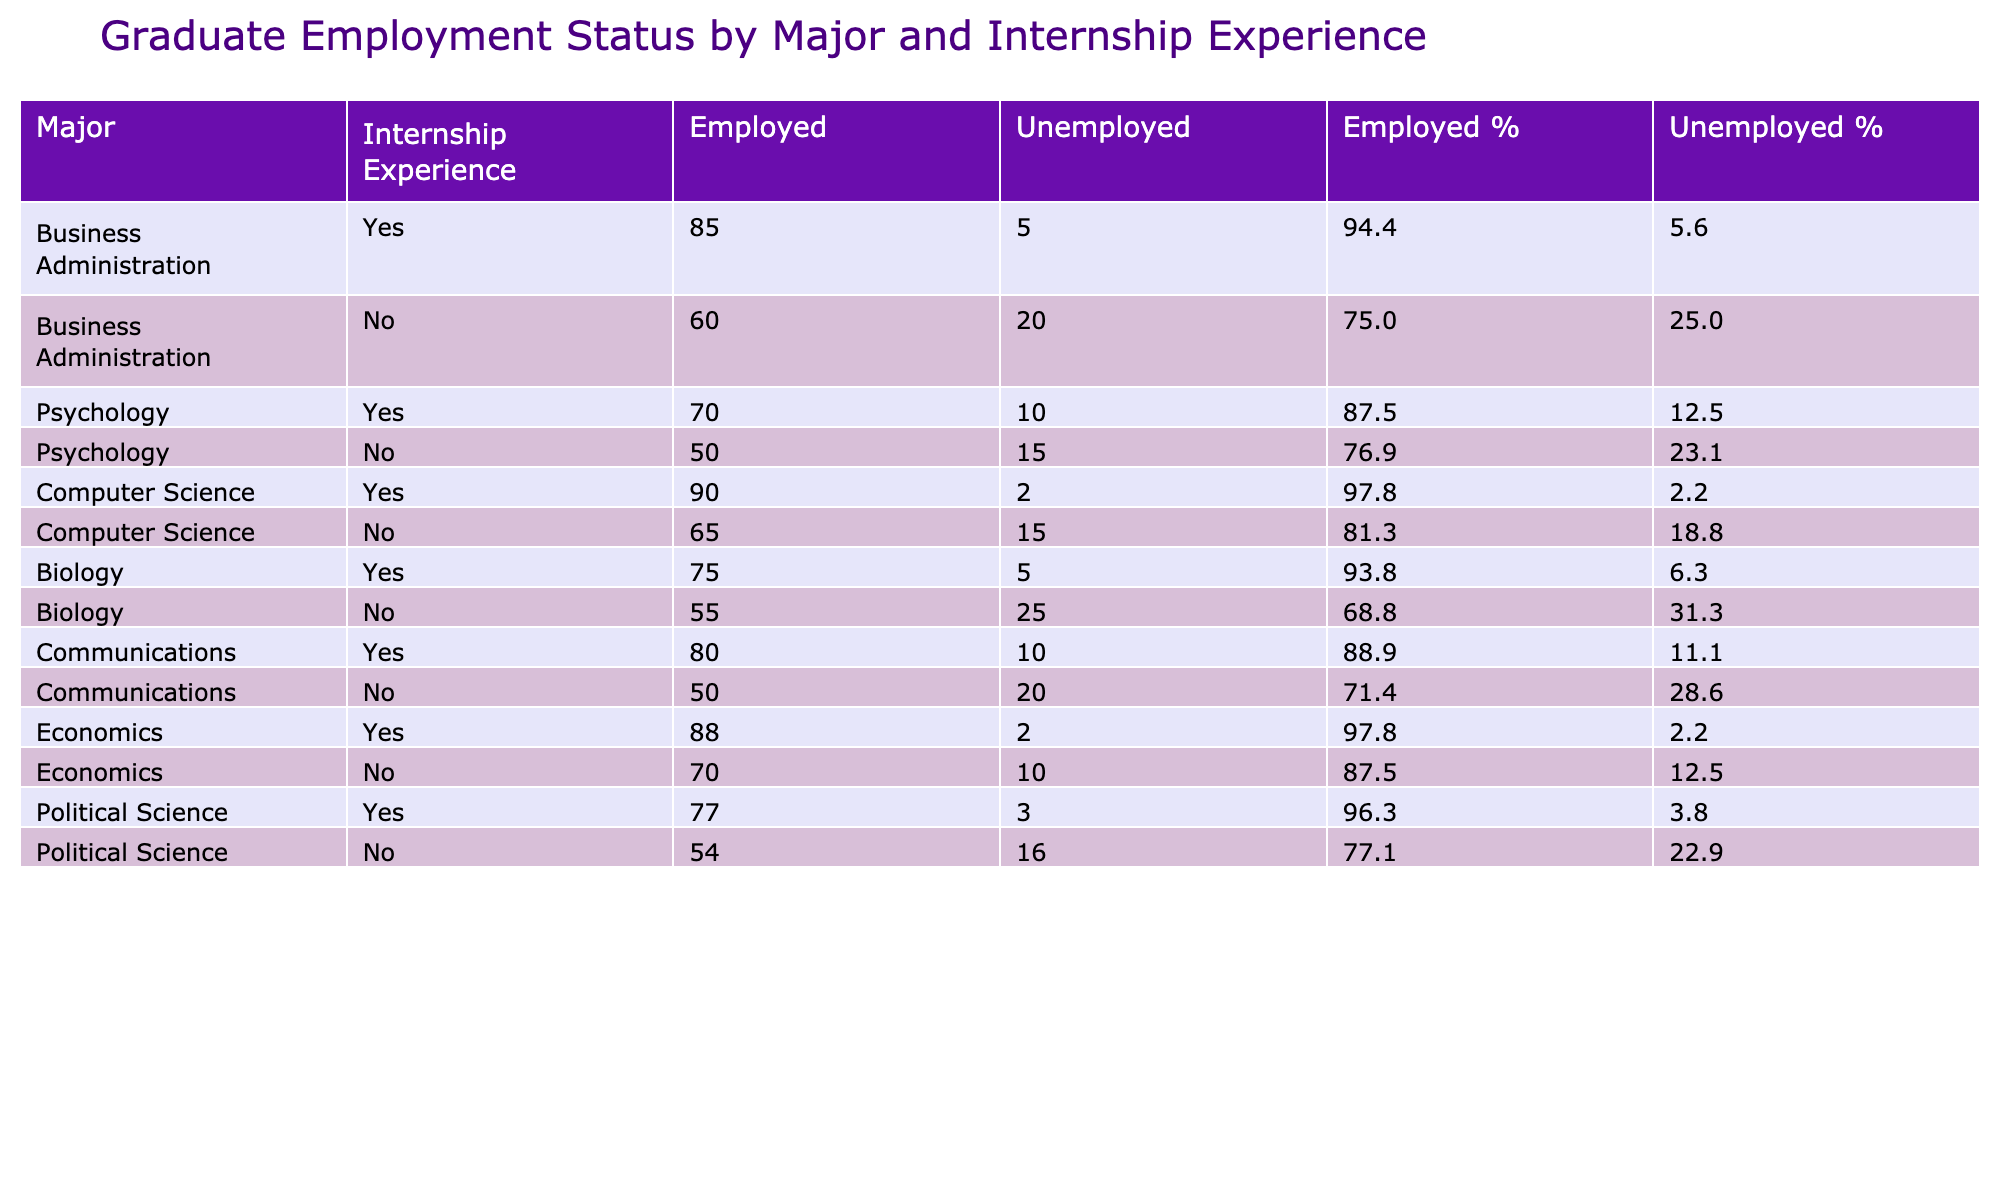What is the employment status of Biology majors with internship experience? According to the table, Biology majors with internship experience have 75 employed and 5 unemployed.
Answer: 75 employed, 5 unemployed How many unemployed Communication majors do not have internship experience? The table shows that Communication majors without internship experience total 20 unemployed.
Answer: 20 unemployed What percentage of Computer Science graduates with internship experience are employed? From the table, Computer Science graduates with internship experience have 90 employed out of a total of 92 (90 employed + 2 unemployed), which gives an employed percentage of (90/92) * 100 ≈ 97.8%.
Answer: Approximately 97.8% How many total graduates from the Psychology major are employed? The employed numbers for Psychology majors are 70 (with internship) and 50 (without internship), summing these gives a total of 70 + 50 = 120 employed Psychology graduates.
Answer: 120 employed Is it true that Economics majors without internship experience have a higher number of unemployed than Biology majors without internship experience? The table shows 10 unemployed Economics majors (no internship) and 25 unemployed Biology majors (no internship), therefore, the statement is false as Biology has more unemployed.
Answer: No What is the difference in the employed count between Business Administration majors with and without internship experience? The table indicates that Business Administration majors with internship experience have 85 employed and those without have 60 employed. The difference is 85 - 60 = 25.
Answer: 25 What is the overall percentage of employed graduates across all majors combined who had internship experience? Adding the employed counts for all majors with internship: (85 + 70 + 90 + 75 + 80 + 88 + 77) = 565. The total counts for all majors with internship: 565 (employed) + (5 + 10 + 2 + 5 + 10 + 2 + 3) = 605; therefore, the percentage is (565 / 605) * 100 ≈ 93.4%.
Answer: Approximately 93.4% How many majors have a higher unemployment rate with internship experience compared to those without internship experience? By examining the table, we find that all majors listed, except for Communications, have a lower unemployment rate with internship experience compared to without. This means 6 majors have a higher unemployment rate without internship experience.
Answer: 6 majors 